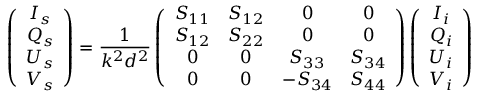Convert formula to latex. <formula><loc_0><loc_0><loc_500><loc_500>\left ( \begin{array} { c c c c } { I _ { s } } \\ { Q _ { s } } \\ { U _ { s } } \\ { V _ { s } } \end{array} \right ) = \frac { 1 } { k ^ { 2 } d ^ { 2 } } \left ( \begin{array} { c c c c } { S _ { 1 1 } } & { S _ { 1 2 } } & { 0 } & { 0 } \\ { S _ { 1 2 } } & { S _ { 2 2 } } & { 0 } & { 0 } \\ { 0 } & { 0 } & { S _ { 3 3 } } & { S _ { 3 4 } } \\ { 0 } & { 0 } & { - S _ { 3 4 } } & { S _ { 4 4 } } \end{array} \right ) \left ( \begin{array} { c c c c } { I _ { i } } \\ { Q _ { i } } \\ { U _ { i } } \\ { V _ { i } } \end{array} \right )</formula> 